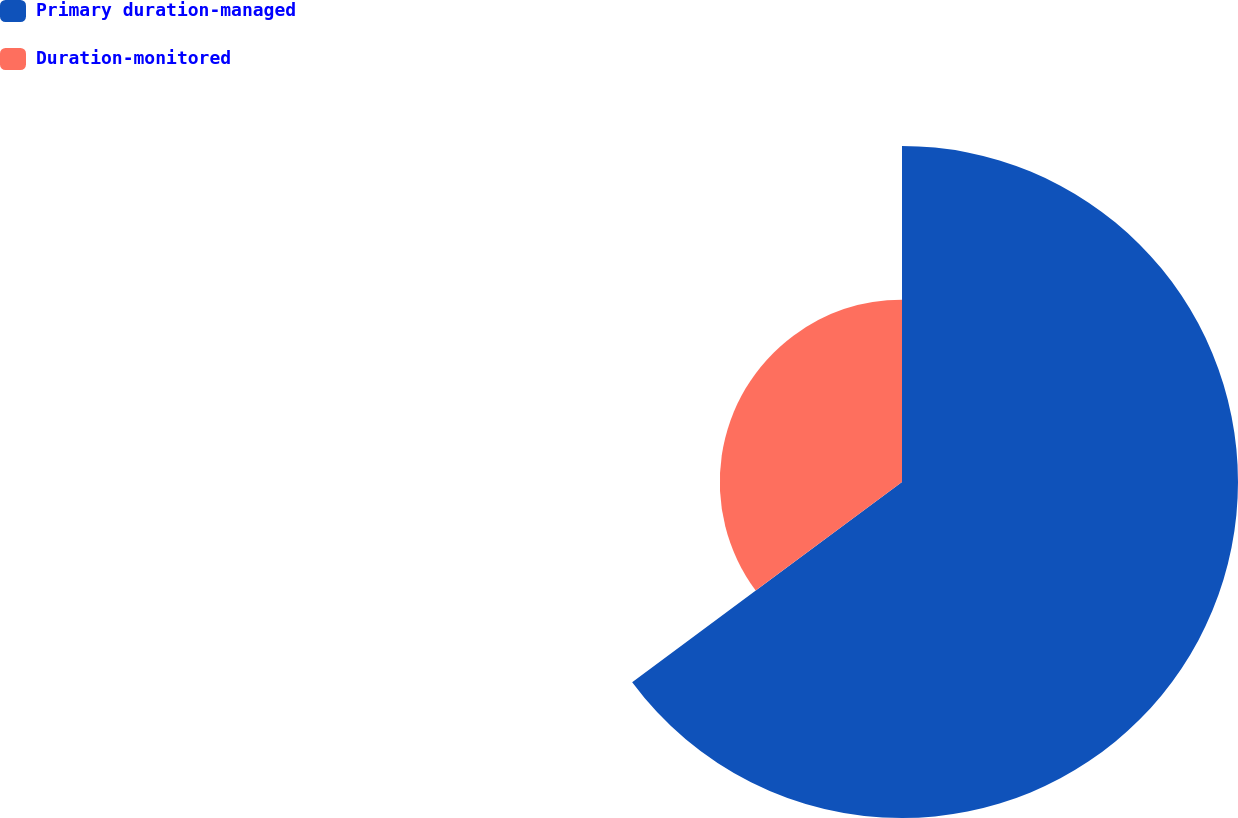Convert chart to OTSL. <chart><loc_0><loc_0><loc_500><loc_500><pie_chart><fcel>Primary duration-managed<fcel>Duration-monitored<nl><fcel>64.84%<fcel>35.16%<nl></chart> 